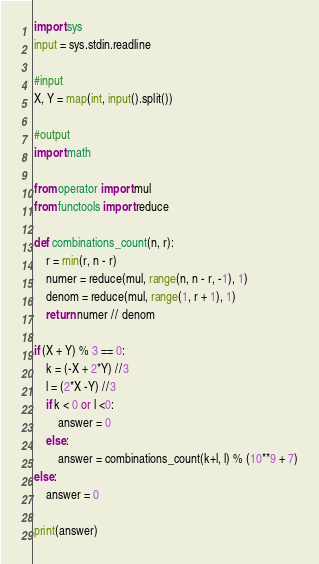Convert code to text. <code><loc_0><loc_0><loc_500><loc_500><_Python_>import sys
input = sys.stdin.readline

#input
X, Y = map(int, input().split())

#output
import math

from operator import mul
from functools import reduce

def combinations_count(n, r):
    r = min(r, n - r)
    numer = reduce(mul, range(n, n - r, -1), 1)
    denom = reduce(mul, range(1, r + 1), 1)
    return numer // denom

if (X + Y) % 3 == 0:
    k = (-X + 2*Y) //3
    l = (2*X -Y) //3
    if k < 0 or l <0:
        answer = 0
    else:
        answer = combinations_count(k+l, l) % (10**9 + 7)
else:
    answer = 0

print(answer)</code> 